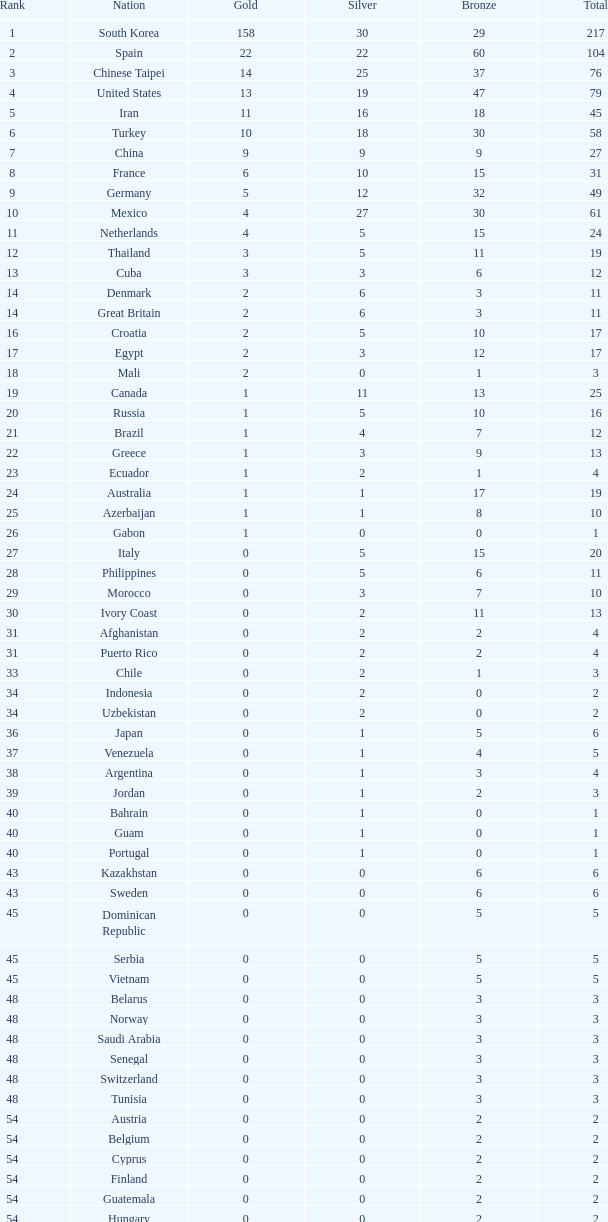What is the total number of medals for the nation ranked 33rd with more than one bronze medal? None. 